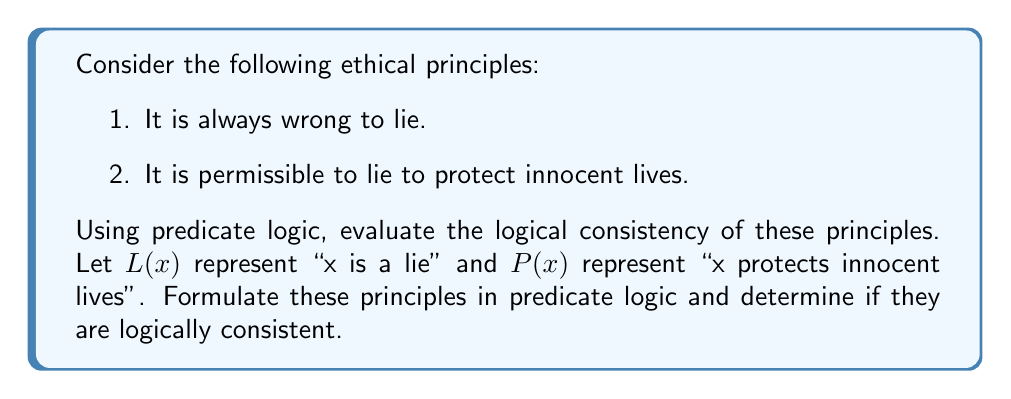Teach me how to tackle this problem. To evaluate the logical consistency of these ethical principles using predicate logic, we'll follow these steps:

1. Formulate the principles in predicate logic:
   Principle 1: $\forall x (L(x) \rightarrow W(x))$
   Where $W(x)$ means "x is wrong"
   This reads as "For all x, if x is a lie, then x is wrong"

   Principle 2: $\exists x (L(x) \land P(x) \land \neg W(x))$
   This reads as "There exists an x such that x is a lie, x protects innocent lives, and x is not wrong"

2. Analyze the logical consistency:
   These principles are logically inconsistent because:
   
   a) From Principle 1, we can derive that all lies are wrong:
      $\forall x (L(x) \rightarrow W(x))$
   
   b) But Principle 2 states that there exists a lie that is not wrong:
      $\exists x (L(x) \land \neg W(x))$
   
   c) These two statements contradict each other. If all lies are wrong, there cannot exist a lie that is not wrong.

3. Formal proof of inconsistency:
   Assume both principles are true:
   
   i.   $\forall x (L(x) \rightarrow W(x))$
   ii.  $\exists x (L(x) \land P(x) \land \neg W(x))$
   
   From ii, let's consider a specific instance 'a' that satisfies the existential quantifier:
   
   iii. $L(a) \land P(a) \land \neg W(a)$
   
   From i, we can instantiate the universal quantifier with 'a':
   
   iv.  $L(a) \rightarrow W(a)$
   
   From iii, we know $L(a)$ is true, so by modus ponens with iv:
   
   v.   $W(a)$
   
   But this contradicts $\neg W(a)$ from iii.

Therefore, these two ethical principles are logically inconsistent in predicate logic.
Answer: The ethical principles are logically inconsistent. The formal predicate logic representation shows that Principle 1 ($\forall x (L(x) \rightarrow W(x))$) contradicts Principle 2 ($\exists x (L(x) \land P(x) \land \neg W(x))$), as it's impossible for all lies to be wrong while simultaneously allowing for the existence of a lie that is not wrong. 